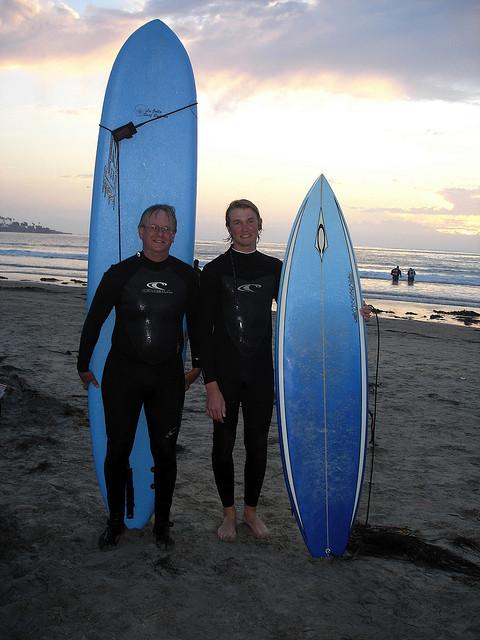What color are the surfboards?
Short answer required. Blue. Are there more than two surfboards on this beach?
Be succinct. No. Are the surfboards the same?
Give a very brief answer. No. Is the man taller than the woman?
Concise answer only. No. What color are the majority of the surfboards?
Short answer required. Blue. Is there a bird in the picture?
Answer briefly. No. Are these surfboards old and ugly?
Write a very short answer. No. 